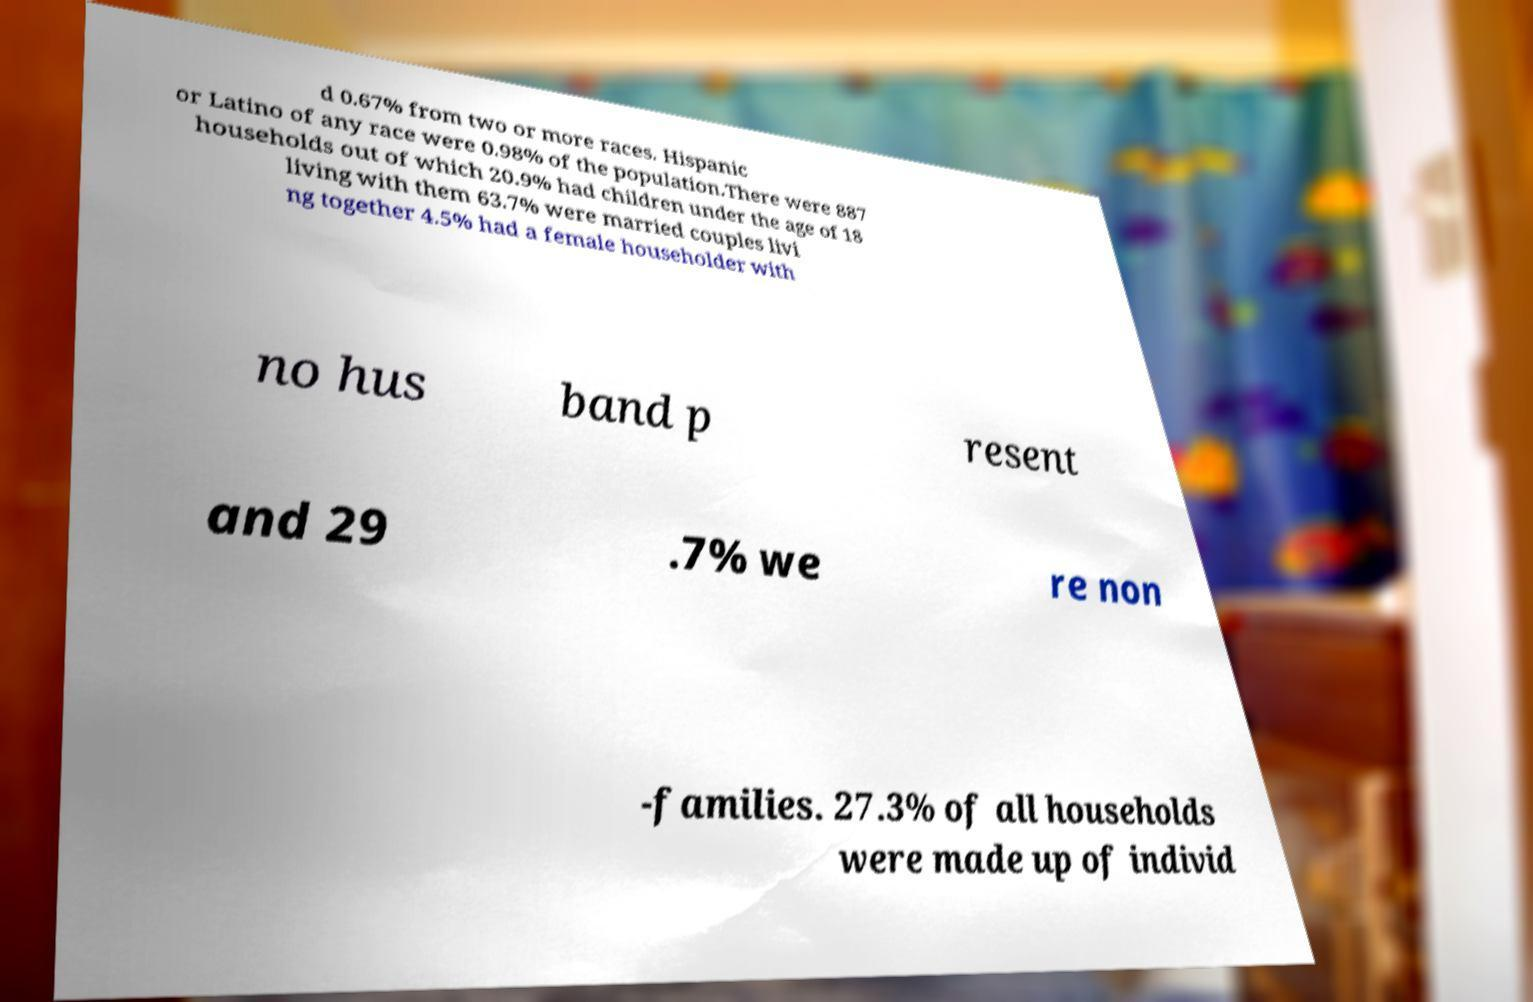There's text embedded in this image that I need extracted. Can you transcribe it verbatim? d 0.67% from two or more races. Hispanic or Latino of any race were 0.98% of the population.There were 887 households out of which 20.9% had children under the age of 18 living with them 63.7% were married couples livi ng together 4.5% had a female householder with no hus band p resent and 29 .7% we re non -families. 27.3% of all households were made up of individ 